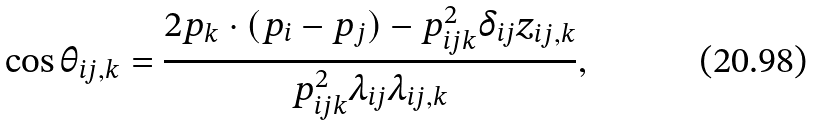<formula> <loc_0><loc_0><loc_500><loc_500>\cos { \theta _ { i j , k } } = \frac { 2 p _ { k } \cdot ( p _ { i } - p _ { j } ) - p _ { i j k } ^ { 2 } \delta _ { i j } z _ { i j , k } } { p _ { i j k } ^ { 2 } \lambda _ { i j } \lambda _ { i j , k } } ,</formula> 